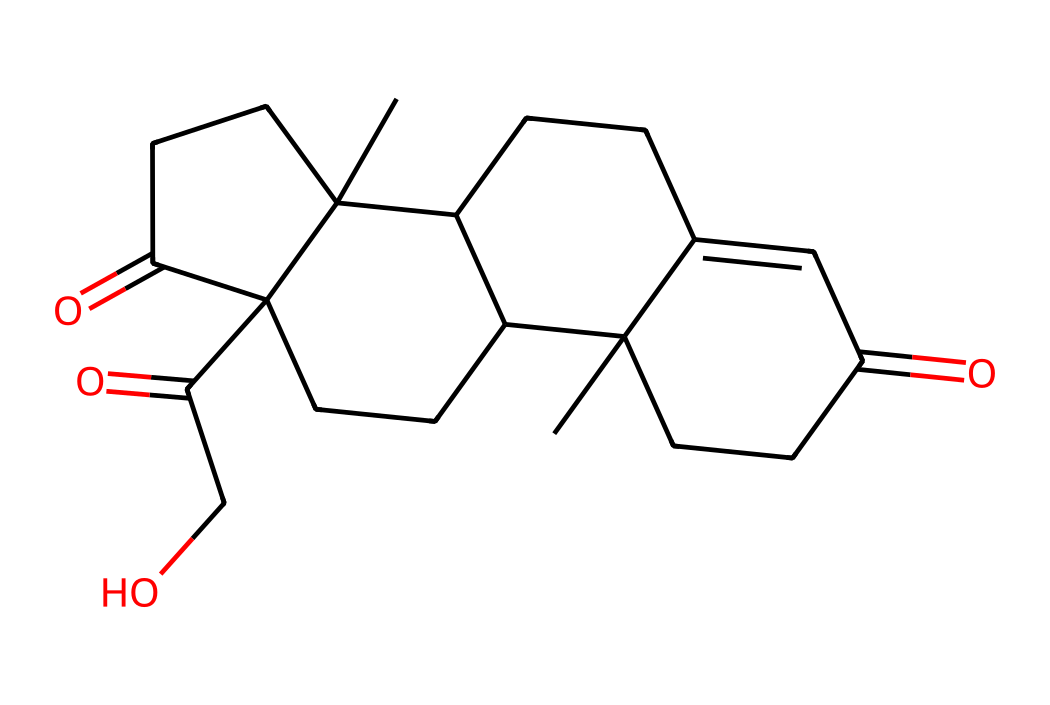What is the molecular formula of cortisol? To determine the molecular formula, we can count the number of each type of atom in the SMILES representation. The SMILES indicates the presence of carbon (C), hydrogen (H), and oxygen (O) atoms. Summing them gives us C21H30O5.
Answer: C21H30O5 How many rings are present in the structure? By analyzing the SMILES, we can identify rings by the numbering of atoms that connect back to previous atoms. The rings can be counted based on the numbers paired in the SMILES. There are four rings in the structure.
Answer: 4 What functional groups can be identified in this molecule? Examining the structure, we note the presence of ketone groups (C=O) and hydroxyl groups (C-OH). The two carbonyls and one hydroxyl make the main functional groups identified.
Answer: ketone and hydroxyl Which component of cortisol is responsible for its biological activity? The biological activity often arises from the hydroxyl (OH) functional groups on the steroid structure. In cortisol, these hydroxyl groups modulate its interaction with specific receptors.
Answer: hydroxyl groups What is the significance of cortisol in the context of stress? Cortisol is known as the "stress hormone," which helps regulate metabolism, immune response, and stress reactions. Its levels increase during stress and facilitate the body's fight-or-flight response.
Answer: stress hormone Is cortisol hydrophilic or hydrophobic? Given the structure's characteristics, specifically the presence of hydroxyl groups, cortisol has both polar (hydrophilic) regions and non-polar (hydrophobic) regions. However, its overall nature is more hydrophobic due to the steroid backbone.
Answer: hydrophobic 